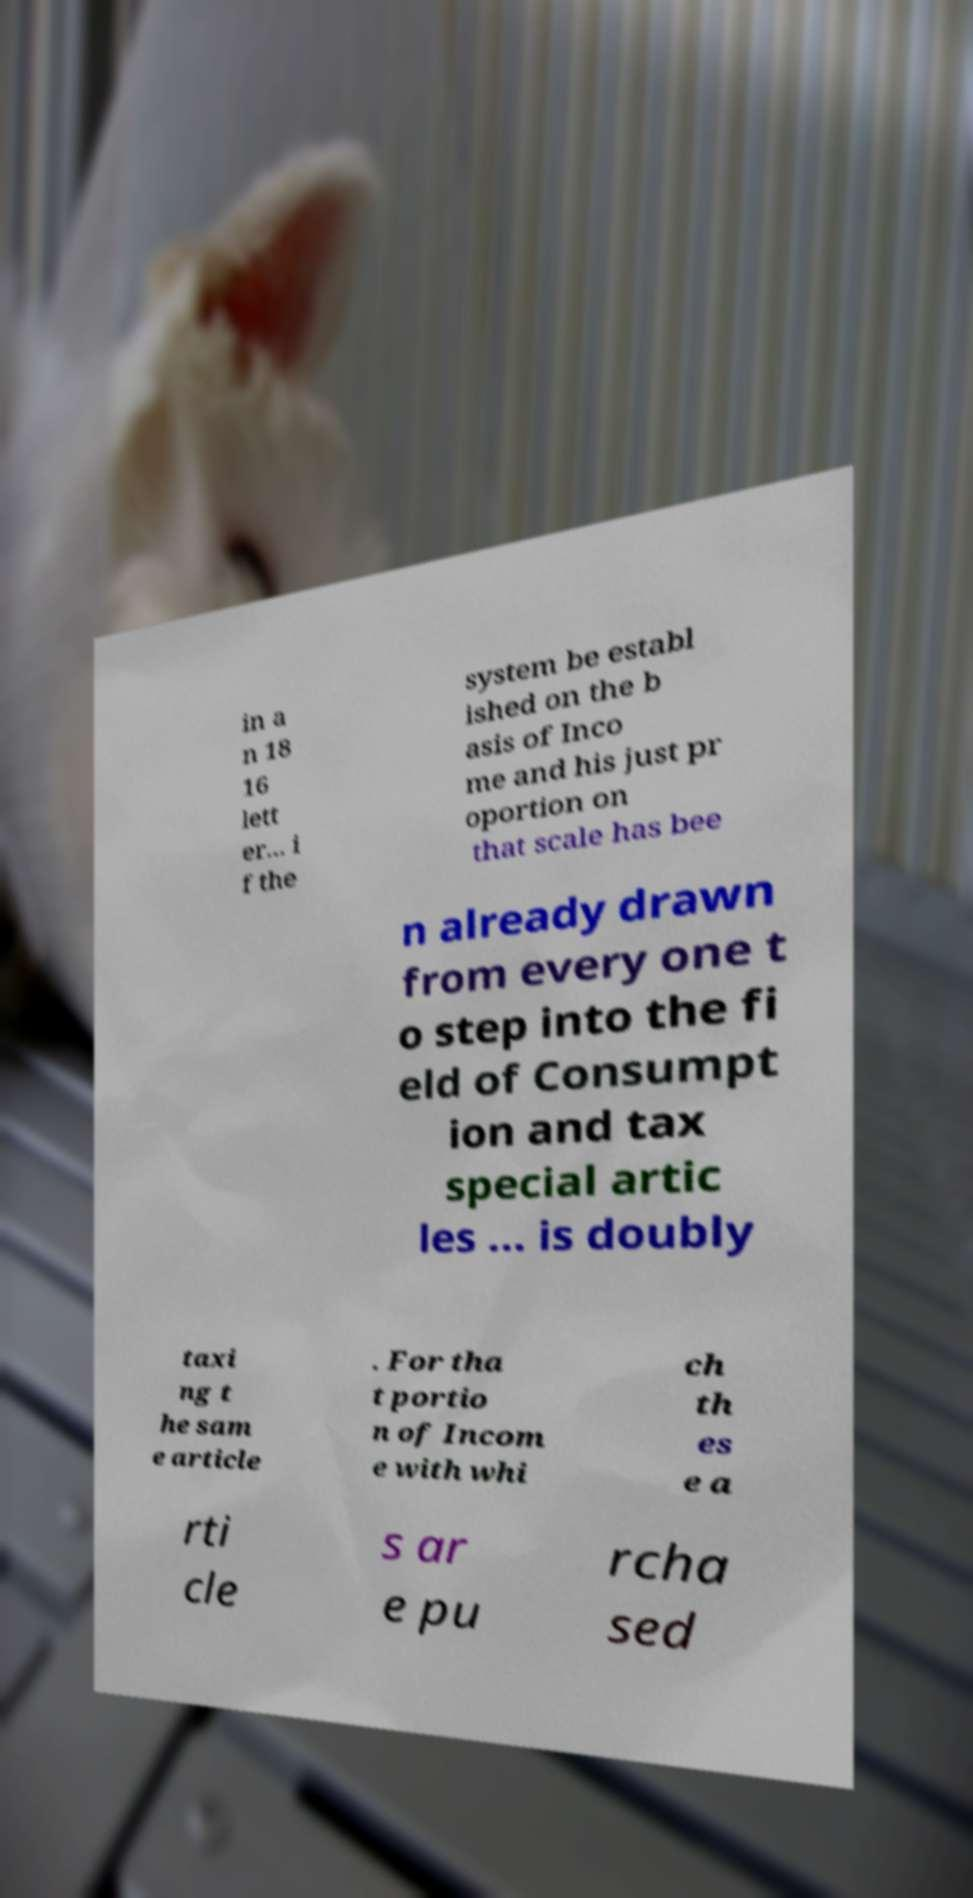Can you read and provide the text displayed in the image?This photo seems to have some interesting text. Can you extract and type it out for me? in a n 18 16 lett er... i f the system be establ ished on the b asis of Inco me and his just pr oportion on that scale has bee n already drawn from every one t o step into the fi eld of Consumpt ion and tax special artic les ... is doubly taxi ng t he sam e article . For tha t portio n of Incom e with whi ch th es e a rti cle s ar e pu rcha sed 